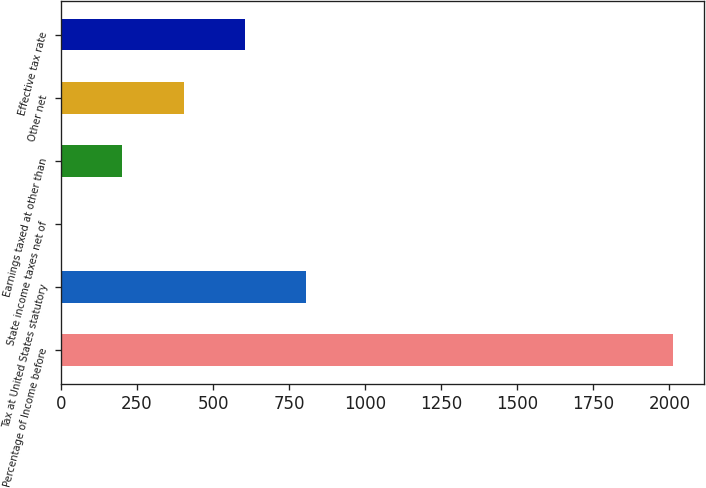Convert chart. <chart><loc_0><loc_0><loc_500><loc_500><bar_chart><fcel>Percentage of Income before<fcel>Tax at United States statutory<fcel>State income taxes net of<fcel>Earnings taxed at other than<fcel>Other net<fcel>Effective tax rate<nl><fcel>2013<fcel>805.44<fcel>0.4<fcel>201.66<fcel>402.92<fcel>604.18<nl></chart> 